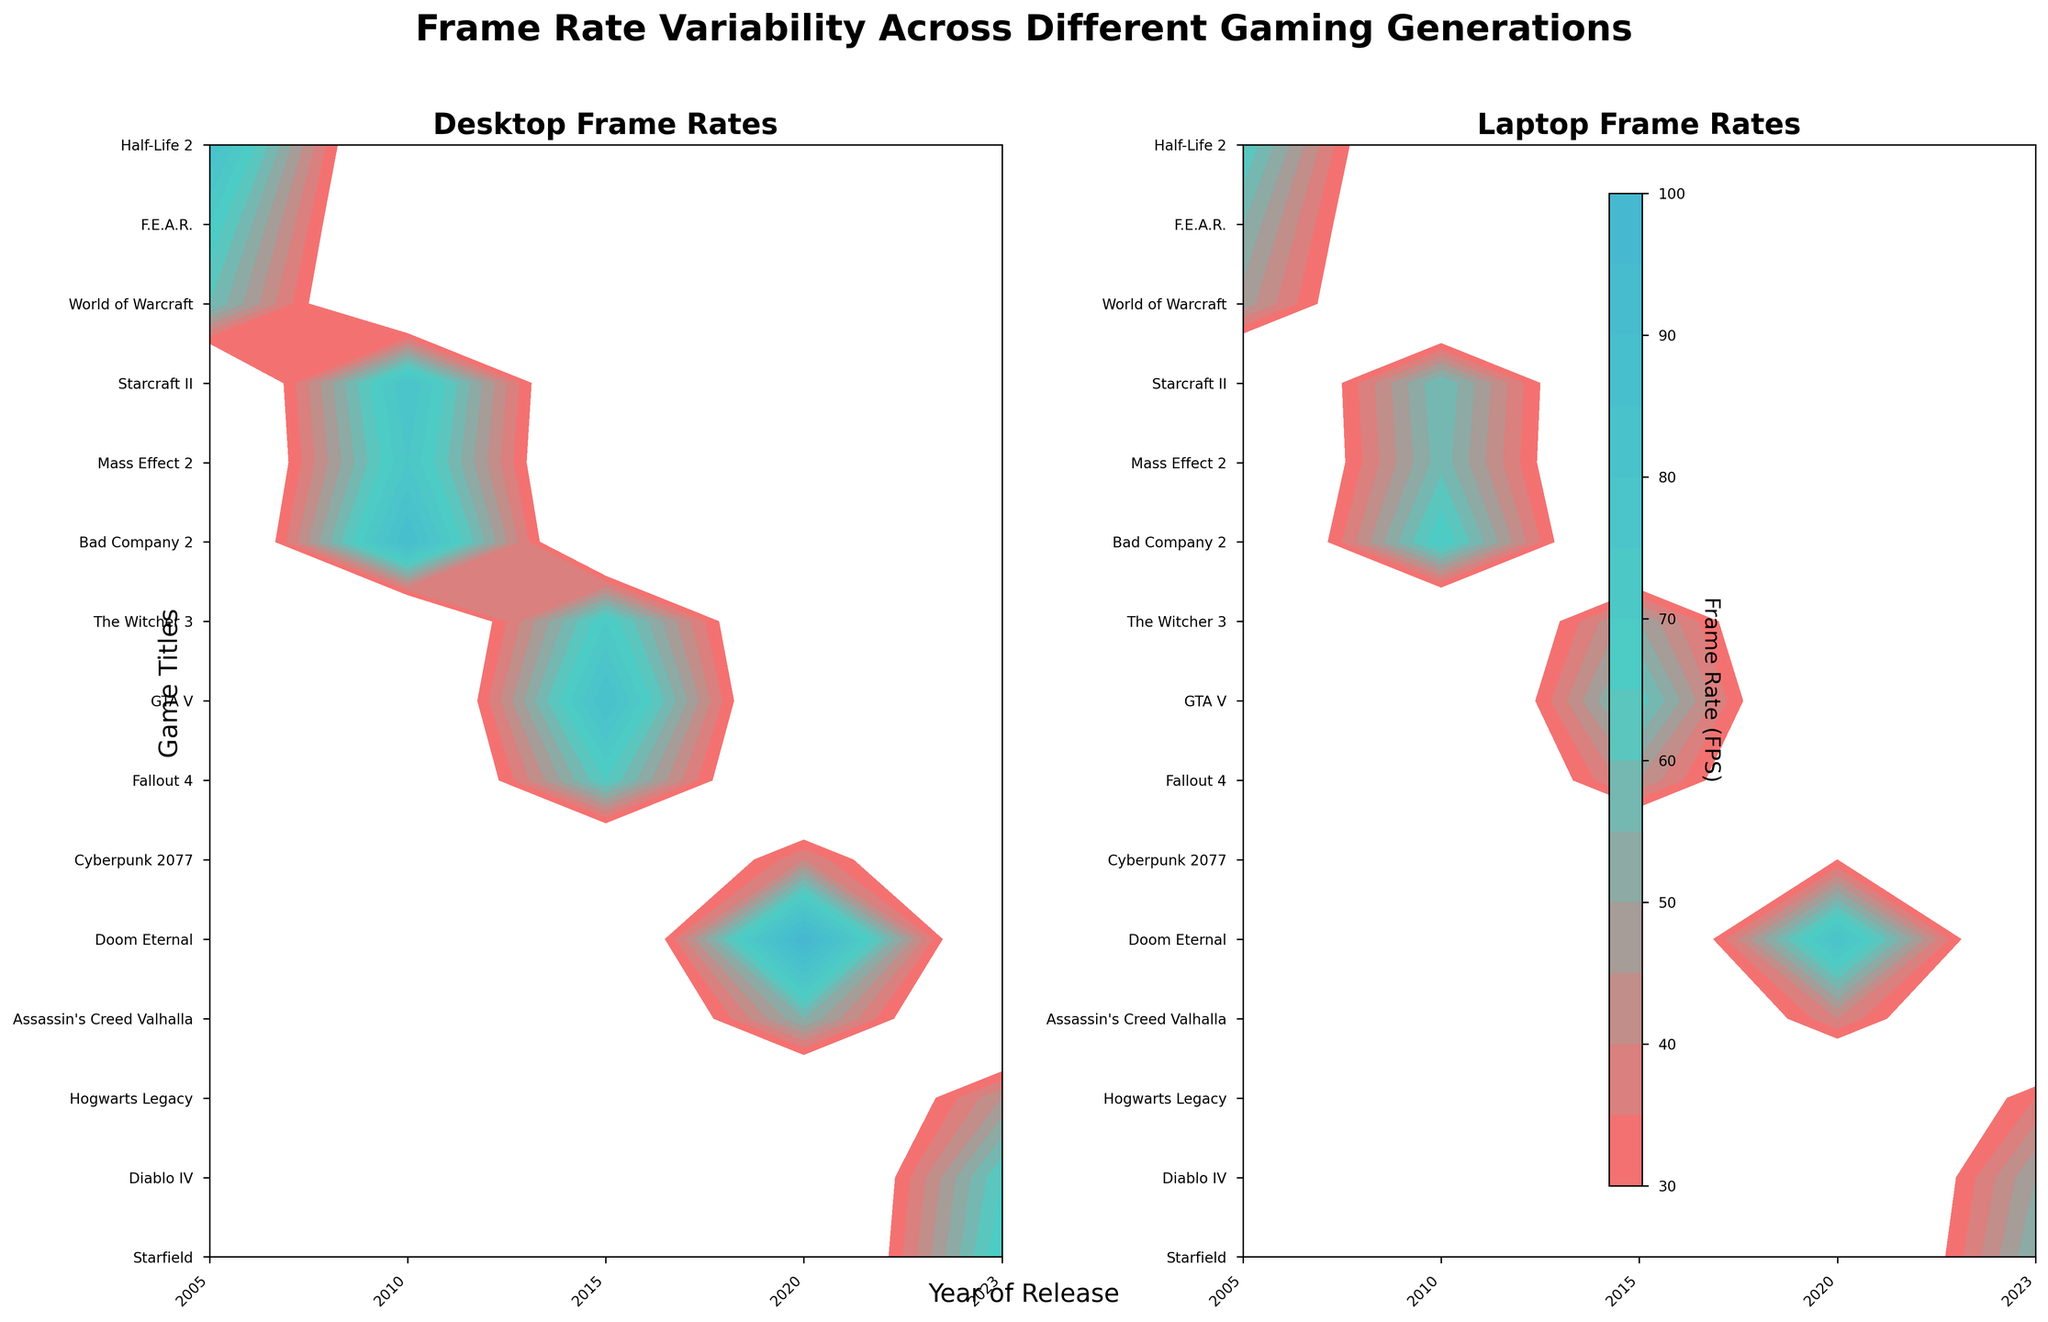What is the title of the figure? The title of the figure is displayed at the very top, written in bold and large font. It reads “Frame Rate Variability Across Different Gaming Generations.”
Answer: Frame Rate Variability Across Different Gaming Generations Which year has the highest desktop frame rate and in which game? Looking at the "Desktop Frame Rates" contour plot, the highest frame rate appears to be in the year 2020 with the game "Doom Eternal," showing a frame rate of 100 FPS.
Answer: 2020, Doom Eternal Which game has the most significant difference between desktop and laptop frame rates? To find the game with the most significant difference, look at both contour plots and identify which game shows the largest visual gap between the corresponding contour levels. "Doom Eternal" in 2020 has a desktop frame rate of 100 FPS and a laptop frame rate of 80 FPS, making the difference 20 FPS.
Answer: Doom Eternal What is the average desktop frame rate for games released in 2023? To calculate the average, look at the "Desktop Frame Rates" plot: Hogwarts Legacy (45 FPS), Diablo IV (65 FPS), and Starfield (70 FPS). The average is (45 + 65 + 70) / 3 = 60 FPS.
Answer: 60 FPS Which platform shows a more significant decline in frame rates from 2015 to 2020? Analyze the frame rates from 2015 to 2020 for both desktop and laptop in the contour plots. Desktop frame rates drop from values like 85 FPS in GTA V (2015) to 40 FPS in Cyberpunk 2077 (2020). For laptops, the drop is from 63 FPS in GTA V (2015) to 30 FPS in Cyberpunk 2077 (2020). Both drops, but laptops drop more.
Answer: Laptop In which year did laptops consistently perform worse across all games compared to desktops? Compare frame rates across years in both plots. For every year, laptop frame rates are consistently lower than desktop frame rates for all games listed.
Answer: Every year What game released in 2010 has the highest laptop frame rate? Inspecting the contour plot for "Laptop Frame Rates," the highest frame rate for a 2010 game is seen in "Bad Company 2," with a laptop frame rate of 70 FPS.
Answer: Bad Company 2 Which game shows the lowest frame rate on laptops? In the "Laptop Frame Rates" contour plot, "Cyberpunk 2077" in 2020 shows the lowest frame rate at 30 FPS.
Answer: Cyberpunk 2077 Do games released in earlier years generally have higher frame rates than games in later years? Observing the overall trend across both contour plots from 2005 to 2023, frame rates for both desktops and laptops tend to decrease over time, indicating a downward trend in frame rates for more recent games as graphical demands increase.
Answer: Yes What is the difference in frame rates for "Hogwarts Legacy" between desktops and laptops? For "Hogwarts Legacy" (2023), the desktop frame rate is 45 FPS, and the laptop frame rate is 35 FPS. The difference is 10 FPS.
Answer: 10 FPS 